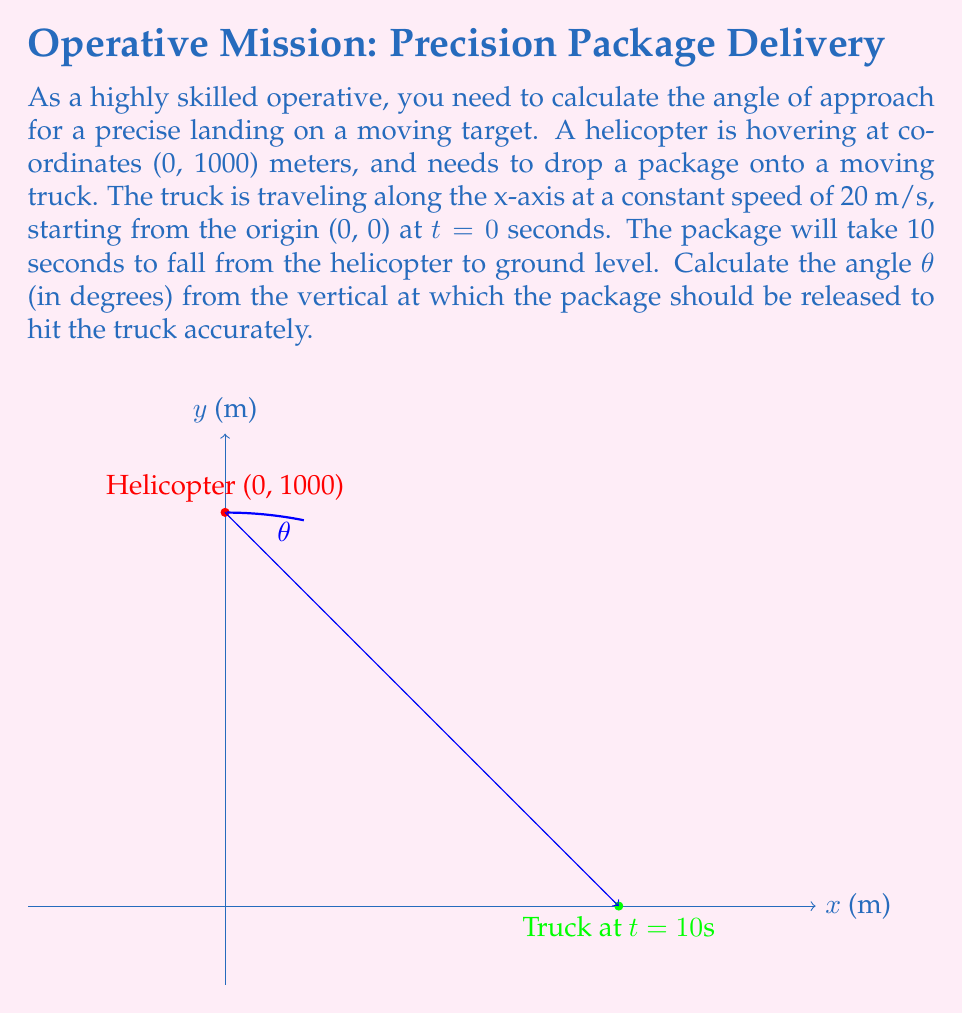Provide a solution to this math problem. Let's approach this step-by-step:

1) First, we need to determine the position of the truck when the package lands. Since the truck travels at 20 m/s for 10 seconds:
   
   $$x = 20 \text{ m/s} \times 10 \text{ s} = 200 \text{ m}$$

2) Now we have two points: the helicopter's position (0, 1000) and the truck's position when the package lands (200, 0).

3) To find the angle, we can use the arctangent function. The tangent of the angle is the ratio of the horizontal distance to the vertical distance:

   $$\tan(\theta) = \frac{\text{horizontal distance}}{\text{vertical distance}} = \frac{200}{1000} = \frac{1}{5}$$

4) Therefore, the angle θ is:

   $$\theta = \arctan(\frac{1}{5})$$

5) Converting this to degrees:

   $$\theta = \arctan(\frac{1}{5}) \times \frac{180}{\pi} \approx 11.31°$$

6) However, this is the angle from the vertical, which is what we need.
Answer: $11.31°$ 